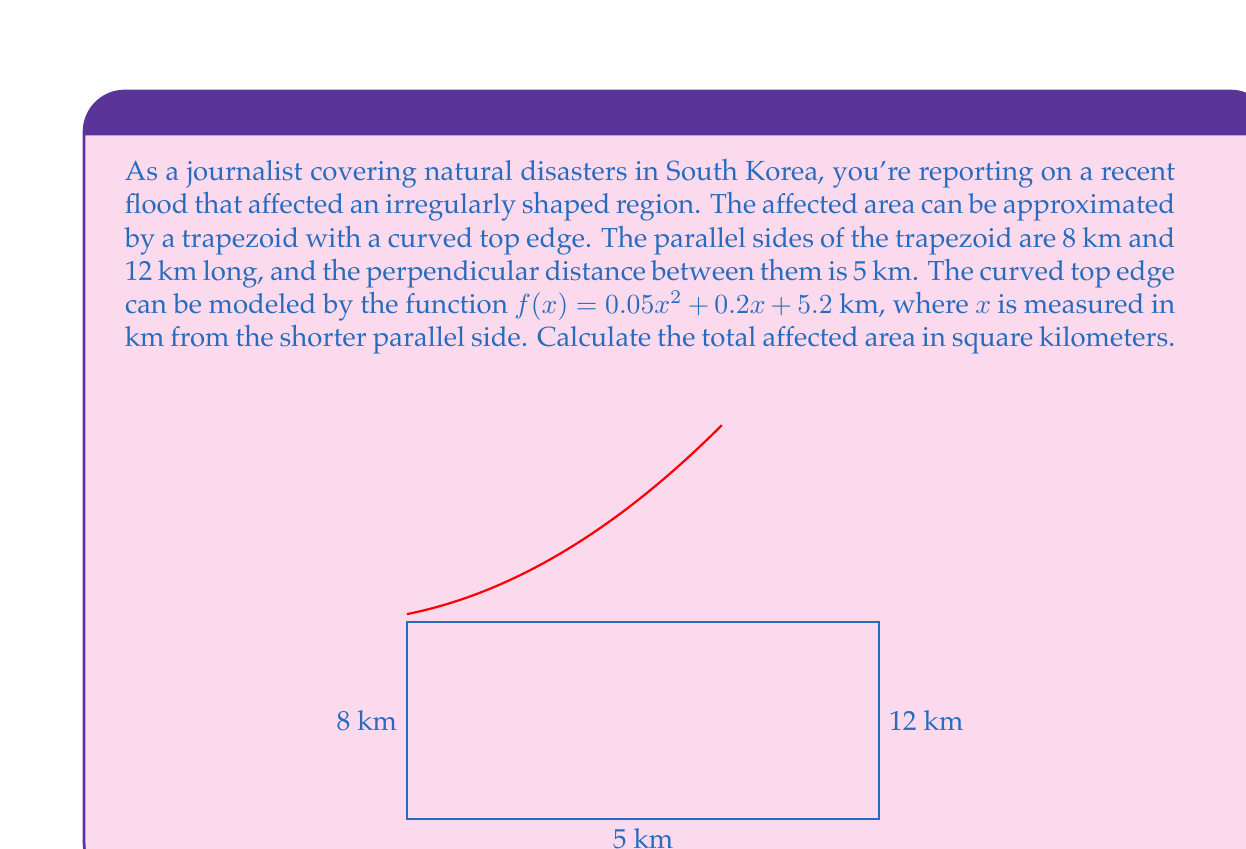Show me your answer to this math problem. To solve this problem, we'll break it down into steps:

1) First, calculate the area of the trapezoid:
   Area of trapezoid = $\frac{1}{2}(a+b)h$
   Where $a$ and $b$ are the parallel sides, and $h$ is the height.
   $$A_{trapezoid} = \frac{1}{2}(8+12) \cdot 5 = 50$$ sq km

2) Next, we need to calculate the area between the curved top edge and the straight top of the trapezoid. This can be done using integration:
   $$A_{curve} = \int_0^8 [f(x) - 5] dx = \int_0^8 (0.05x^2 + 0.2x + 0.2) dx$$

3) Integrate:
   $$A_{curve} = [\frac{0.05x^3}{3} + \frac{0.2x^2}{2} + 0.2x]_0^8$$

4) Evaluate the integral:
   $$A_{curve} = (\frac{0.05 \cdot 8^3}{3} + \frac{0.2 \cdot 8^2}{2} + 0.2 \cdot 8) - (0)$$
   $$= (\frac{256}{15} + 6.4 + 1.6) = 25.0667$$ sq km

5) The total affected area is the sum of the trapezoid area and the curved area:
   $$A_{total} = A_{trapezoid} + A_{curve} = 50 + 25.0667 = 75.0667$$ sq km
Answer: The total affected area is approximately 75.07 square kilometers. 